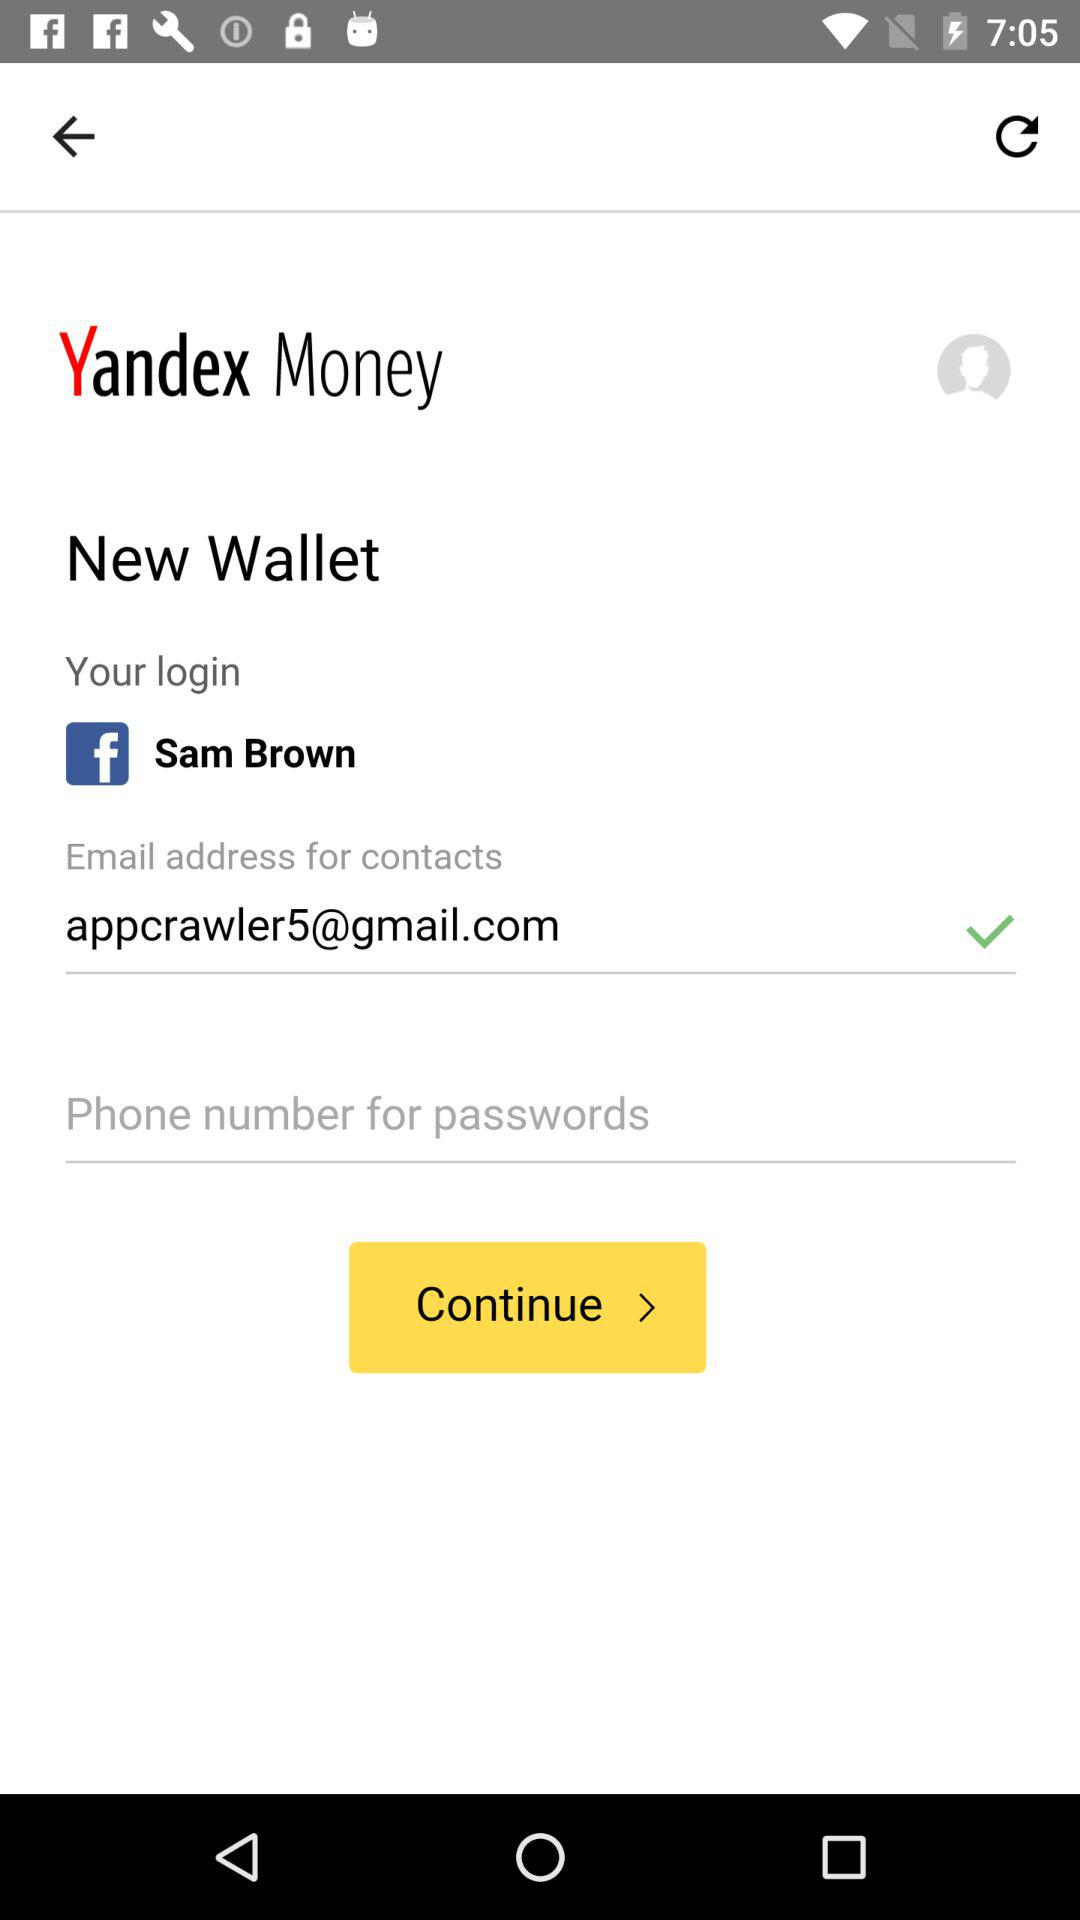What is the name of the application? The name of the application is "Yandex Money". 